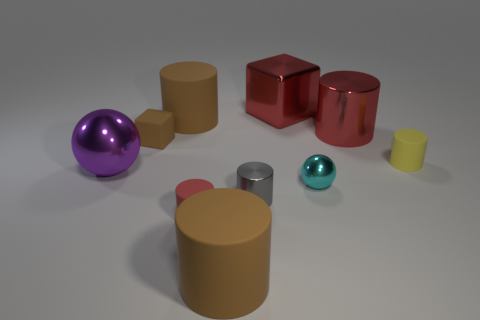What is the size of the metal cylinder that is the same color as the large block?
Your answer should be compact. Large. Are there any tiny metallic balls?
Make the answer very short. Yes. There is a shiny object that is behind the large brown cylinder behind the red matte object; what color is it?
Your response must be concise. Red. There is a big thing that is the same shape as the tiny brown object; what is it made of?
Offer a terse response. Metal. How many metal things are the same size as the red matte object?
Offer a very short reply. 2. The other sphere that is the same material as the small sphere is what size?
Keep it short and to the point. Large. How many tiny brown matte objects are the same shape as the yellow rubber object?
Offer a very short reply. 0. How many large brown objects are there?
Ensure brevity in your answer.  2. There is a big brown thing to the left of the red matte cylinder; is it the same shape as the yellow object?
Offer a terse response. Yes. There is a brown object that is the same size as the cyan metallic thing; what is its material?
Ensure brevity in your answer.  Rubber. 